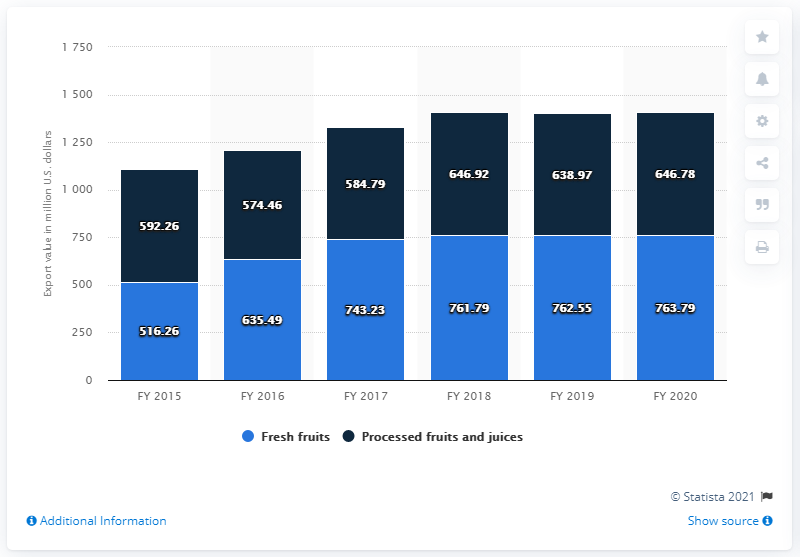List a handful of essential elements in this visual. In the fiscal year 2020, the value of fresh fruit exports from India was 763.79 million. In the fiscal year 2020, the value of processed fruits and juices exported from India was 646.78 million. 